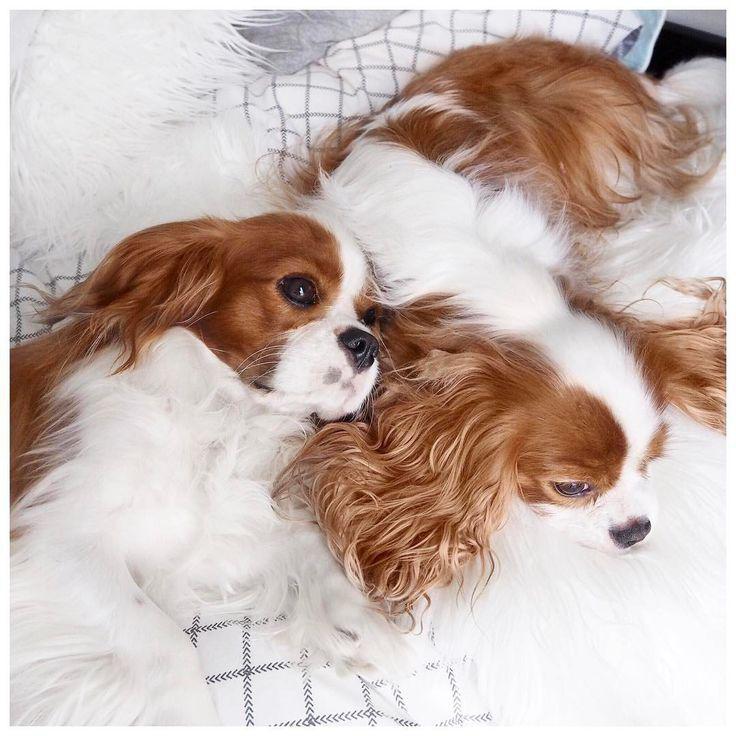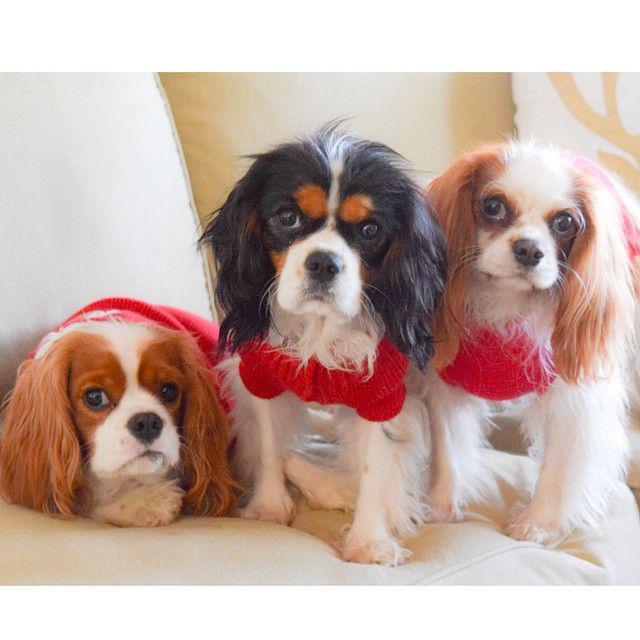The first image is the image on the left, the second image is the image on the right. Analyze the images presented: Is the assertion "One of the brown and white dogs has a toy." valid? Answer yes or no. No. The first image is the image on the left, the second image is the image on the right. For the images shown, is this caption "All the dogs are looking straight ahead." true? Answer yes or no. No. 